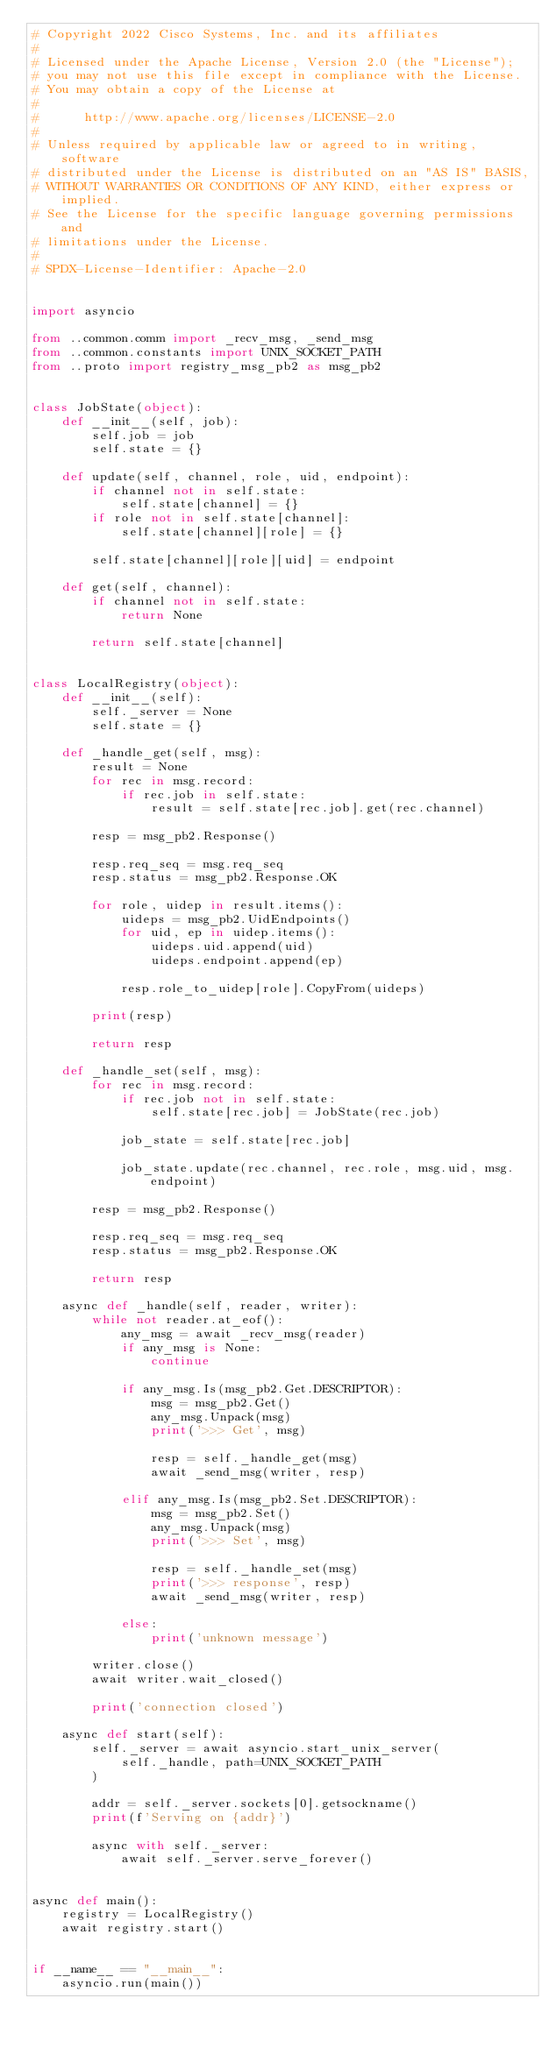Convert code to text. <code><loc_0><loc_0><loc_500><loc_500><_Python_># Copyright 2022 Cisco Systems, Inc. and its affiliates
#
# Licensed under the Apache License, Version 2.0 (the "License");
# you may not use this file except in compliance with the License.
# You may obtain a copy of the License at
#
#      http://www.apache.org/licenses/LICENSE-2.0
#
# Unless required by applicable law or agreed to in writing, software
# distributed under the License is distributed on an "AS IS" BASIS,
# WITHOUT WARRANTIES OR CONDITIONS OF ANY KIND, either express or implied.
# See the License for the specific language governing permissions and
# limitations under the License.
#
# SPDX-License-Identifier: Apache-2.0


import asyncio

from ..common.comm import _recv_msg, _send_msg
from ..common.constants import UNIX_SOCKET_PATH
from ..proto import registry_msg_pb2 as msg_pb2


class JobState(object):
    def __init__(self, job):
        self.job = job
        self.state = {}

    def update(self, channel, role, uid, endpoint):
        if channel not in self.state:
            self.state[channel] = {}
        if role not in self.state[channel]:
            self.state[channel][role] = {}

        self.state[channel][role][uid] = endpoint

    def get(self, channel):
        if channel not in self.state:
            return None

        return self.state[channel]


class LocalRegistry(object):
    def __init__(self):
        self._server = None
        self.state = {}

    def _handle_get(self, msg):
        result = None
        for rec in msg.record:
            if rec.job in self.state:
                result = self.state[rec.job].get(rec.channel)

        resp = msg_pb2.Response()

        resp.req_seq = msg.req_seq
        resp.status = msg_pb2.Response.OK

        for role, uidep in result.items():
            uideps = msg_pb2.UidEndpoints()
            for uid, ep in uidep.items():
                uideps.uid.append(uid)
                uideps.endpoint.append(ep)

            resp.role_to_uidep[role].CopyFrom(uideps)

        print(resp)

        return resp

    def _handle_set(self, msg):
        for rec in msg.record:
            if rec.job not in self.state:
                self.state[rec.job] = JobState(rec.job)

            job_state = self.state[rec.job]

            job_state.update(rec.channel, rec.role, msg.uid, msg.endpoint)

        resp = msg_pb2.Response()

        resp.req_seq = msg.req_seq
        resp.status = msg_pb2.Response.OK

        return resp

    async def _handle(self, reader, writer):
        while not reader.at_eof():
            any_msg = await _recv_msg(reader)
            if any_msg is None:
                continue

            if any_msg.Is(msg_pb2.Get.DESCRIPTOR):
                msg = msg_pb2.Get()
                any_msg.Unpack(msg)
                print('>>> Get', msg)

                resp = self._handle_get(msg)
                await _send_msg(writer, resp)

            elif any_msg.Is(msg_pb2.Set.DESCRIPTOR):
                msg = msg_pb2.Set()
                any_msg.Unpack(msg)
                print('>>> Set', msg)

                resp = self._handle_set(msg)
                print('>>> response', resp)
                await _send_msg(writer, resp)

            else:
                print('unknown message')

        writer.close()
        await writer.wait_closed()

        print('connection closed')

    async def start(self):
        self._server = await asyncio.start_unix_server(
            self._handle, path=UNIX_SOCKET_PATH
        )

        addr = self._server.sockets[0].getsockname()
        print(f'Serving on {addr}')

        async with self._server:
            await self._server.serve_forever()


async def main():
    registry = LocalRegistry()
    await registry.start()


if __name__ == "__main__":
    asyncio.run(main())
</code> 